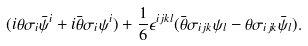Convert formula to latex. <formula><loc_0><loc_0><loc_500><loc_500>( i \theta \sigma _ { i } \bar { \psi } ^ { i } + i \bar { \theta } \sigma _ { i } \psi ^ { i } ) + \frac { 1 } { 6 } \epsilon ^ { i j k l } ( \bar { \theta } \sigma _ { i j k } \psi _ { l } - \theta \sigma _ { i j k } \bar { \psi } _ { l } ) .</formula> 